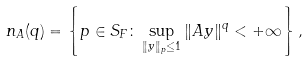Convert formula to latex. <formula><loc_0><loc_0><loc_500><loc_500>n _ { A } ( q ) = \left \{ p \in S _ { F } \colon \sup _ { \| y \| _ { p } \leq 1 } \| A y \| ^ { q } < + \infty \right \} ,</formula> 